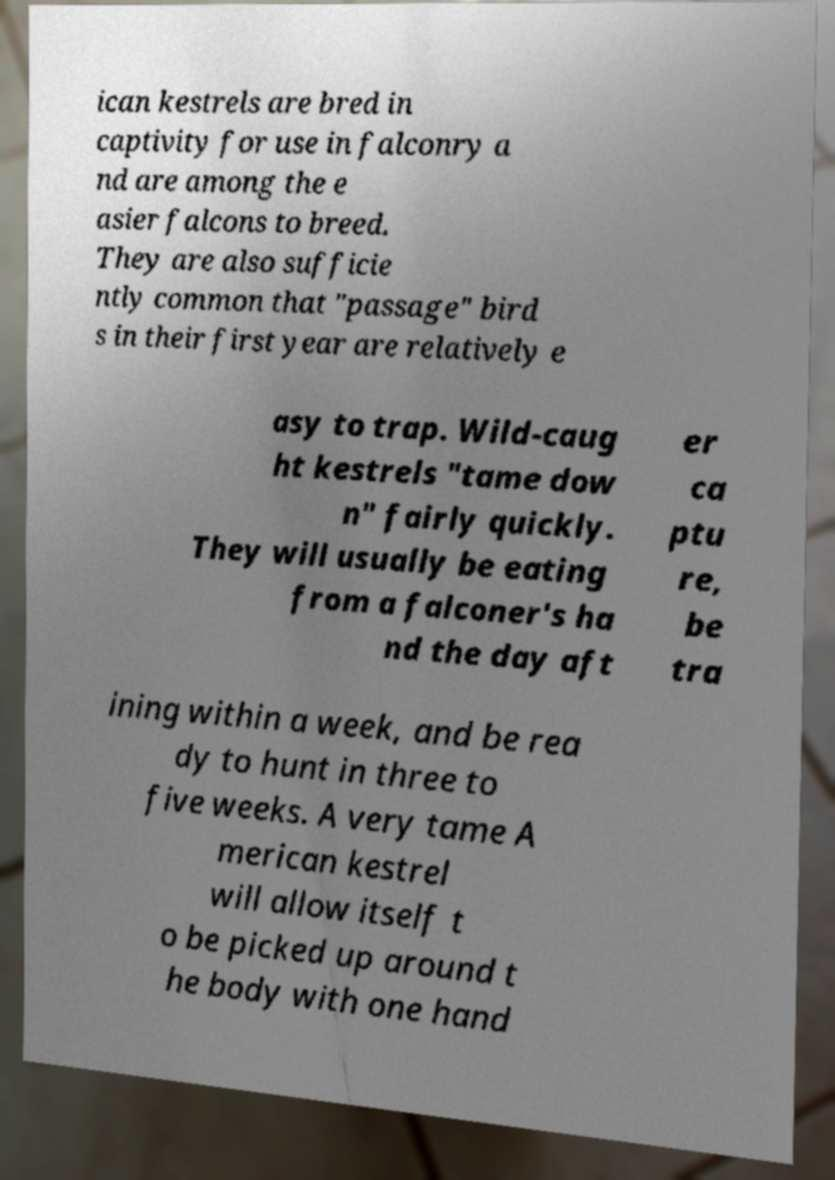Could you extract and type out the text from this image? ican kestrels are bred in captivity for use in falconry a nd are among the e asier falcons to breed. They are also sufficie ntly common that "passage" bird s in their first year are relatively e asy to trap. Wild-caug ht kestrels "tame dow n" fairly quickly. They will usually be eating from a falconer's ha nd the day aft er ca ptu re, be tra ining within a week, and be rea dy to hunt in three to five weeks. A very tame A merican kestrel will allow itself t o be picked up around t he body with one hand 